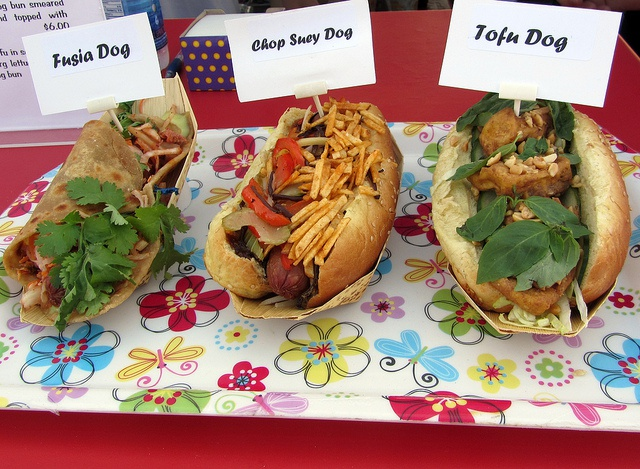Describe the objects in this image and their specific colors. I can see dining table in lavender, lightgray, brown, and maroon tones, sandwich in lavender, darkgreen, olive, tan, and khaki tones, hot dog in lavender, brown, tan, maroon, and orange tones, and sandwich in lavender, darkgreen, tan, and olive tones in this image. 